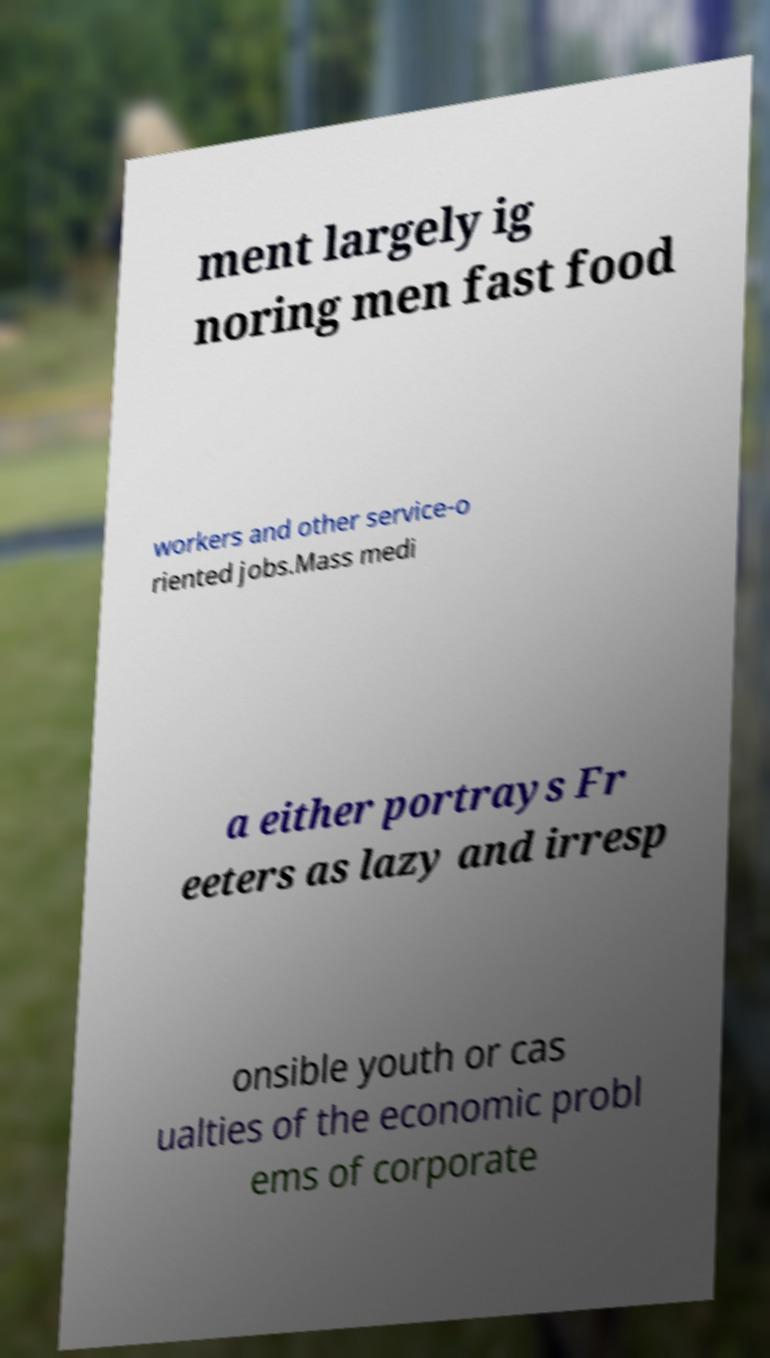Could you extract and type out the text from this image? ment largely ig noring men fast food workers and other service-o riented jobs.Mass medi a either portrays Fr eeters as lazy and irresp onsible youth or cas ualties of the economic probl ems of corporate 